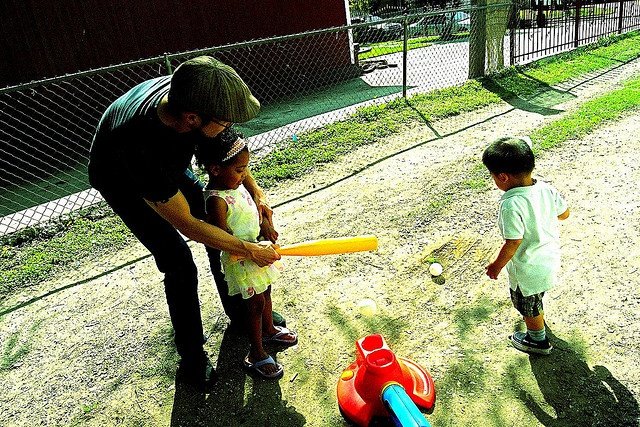Describe the objects in this image and their specific colors. I can see people in black, maroon, and olive tones, people in black, ivory, lightgreen, and maroon tones, people in black, maroon, olive, and beige tones, baseball bat in black, gold, orange, ivory, and red tones, and car in black, gray, white, and darkgray tones in this image. 